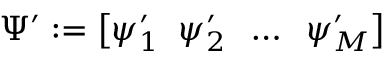<formula> <loc_0><loc_0><loc_500><loc_500>\Psi ^ { \prime } \colon = \left [ \psi _ { 1 } ^ { \prime } \, \psi _ { 2 } ^ { \prime } \, \dots \, \psi _ { M } ^ { \prime } \right ]</formula> 